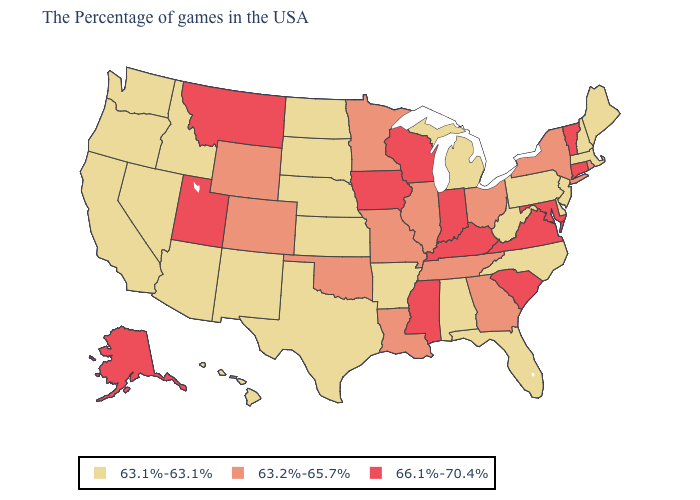Does the first symbol in the legend represent the smallest category?
Short answer required. Yes. Does the first symbol in the legend represent the smallest category?
Be succinct. Yes. Is the legend a continuous bar?
Keep it brief. No. Does the first symbol in the legend represent the smallest category?
Answer briefly. Yes. What is the value of Alaska?
Concise answer only. 66.1%-70.4%. Does New Hampshire have the lowest value in the Northeast?
Short answer required. Yes. Name the states that have a value in the range 63.1%-63.1%?
Give a very brief answer. Maine, Massachusetts, New Hampshire, New Jersey, Delaware, Pennsylvania, North Carolina, West Virginia, Florida, Michigan, Alabama, Arkansas, Kansas, Nebraska, Texas, South Dakota, North Dakota, New Mexico, Arizona, Idaho, Nevada, California, Washington, Oregon, Hawaii. Does New Mexico have the lowest value in the West?
Quick response, please. Yes. What is the value of Mississippi?
Quick response, please. 66.1%-70.4%. What is the value of Montana?
Give a very brief answer. 66.1%-70.4%. What is the lowest value in the USA?
Quick response, please. 63.1%-63.1%. Which states hav the highest value in the MidWest?
Be succinct. Indiana, Wisconsin, Iowa. Does the map have missing data?
Quick response, please. No. Which states hav the highest value in the Northeast?
Concise answer only. Vermont, Connecticut. Name the states that have a value in the range 66.1%-70.4%?
Write a very short answer. Vermont, Connecticut, Maryland, Virginia, South Carolina, Kentucky, Indiana, Wisconsin, Mississippi, Iowa, Utah, Montana, Alaska. 